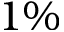Convert formula to latex. <formula><loc_0><loc_0><loc_500><loc_500>1 \%</formula> 